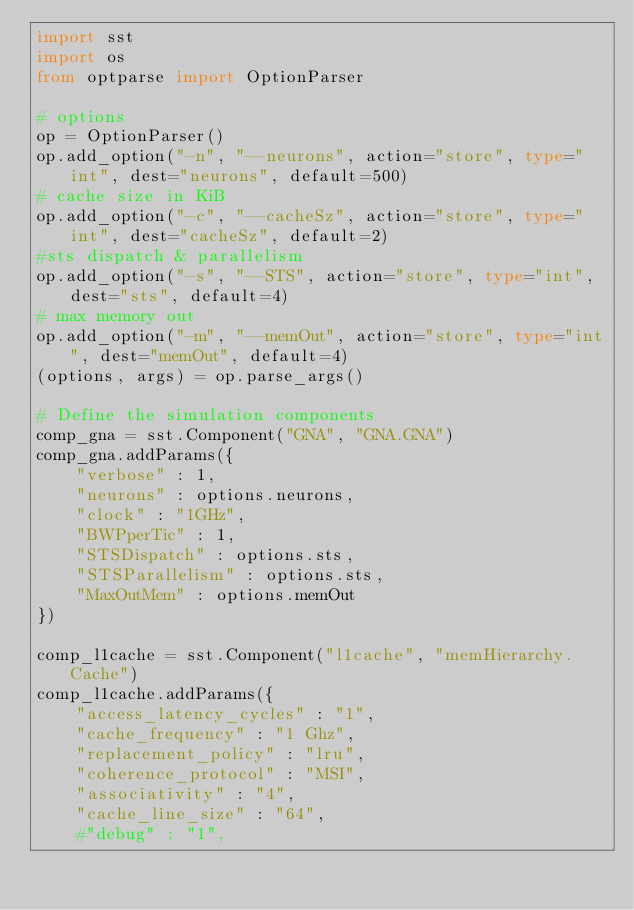<code> <loc_0><loc_0><loc_500><loc_500><_Python_>import sst
import os
from optparse import OptionParser

# options
op = OptionParser()
op.add_option("-n", "--neurons", action="store", type="int", dest="neurons", default=500)
# cache size in KiB
op.add_option("-c", "--cacheSz", action="store", type="int", dest="cacheSz", default=2)
#sts dispatch & parallelism
op.add_option("-s", "--STS", action="store", type="int", dest="sts", default=4)
# max memory out
op.add_option("-m", "--memOut", action="store", type="int", dest="memOut", default=4)
(options, args) = op.parse_args()

# Define the simulation components
comp_gna = sst.Component("GNA", "GNA.GNA")
comp_gna.addParams({
    "verbose" : 1,
    "neurons" : options.neurons,
    "clock" : "1GHz",
    "BWPperTic" : 1,
    "STSDispatch" : options.sts,
    "STSParallelism" : options.sts,
    "MaxOutMem" : options.memOut 
})

comp_l1cache = sst.Component("l1cache", "memHierarchy.Cache")
comp_l1cache.addParams({
    "access_latency_cycles" : "1",
    "cache_frequency" : "1 Ghz",
    "replacement_policy" : "lru",
    "coherence_protocol" : "MSI",
    "associativity" : "4",
    "cache_line_size" : "64",
    #"debug" : "1",</code> 